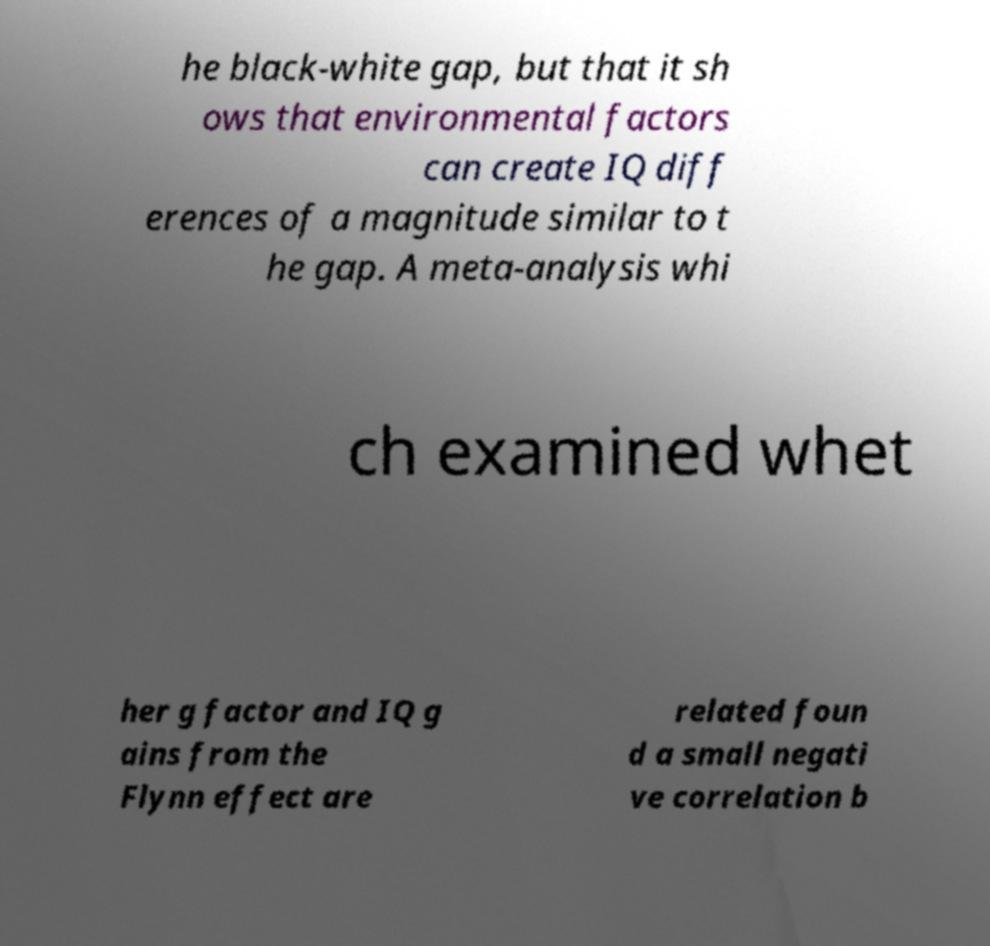I need the written content from this picture converted into text. Can you do that? he black-white gap, but that it sh ows that environmental factors can create IQ diff erences of a magnitude similar to t he gap. A meta-analysis whi ch examined whet her g factor and IQ g ains from the Flynn effect are related foun d a small negati ve correlation b 